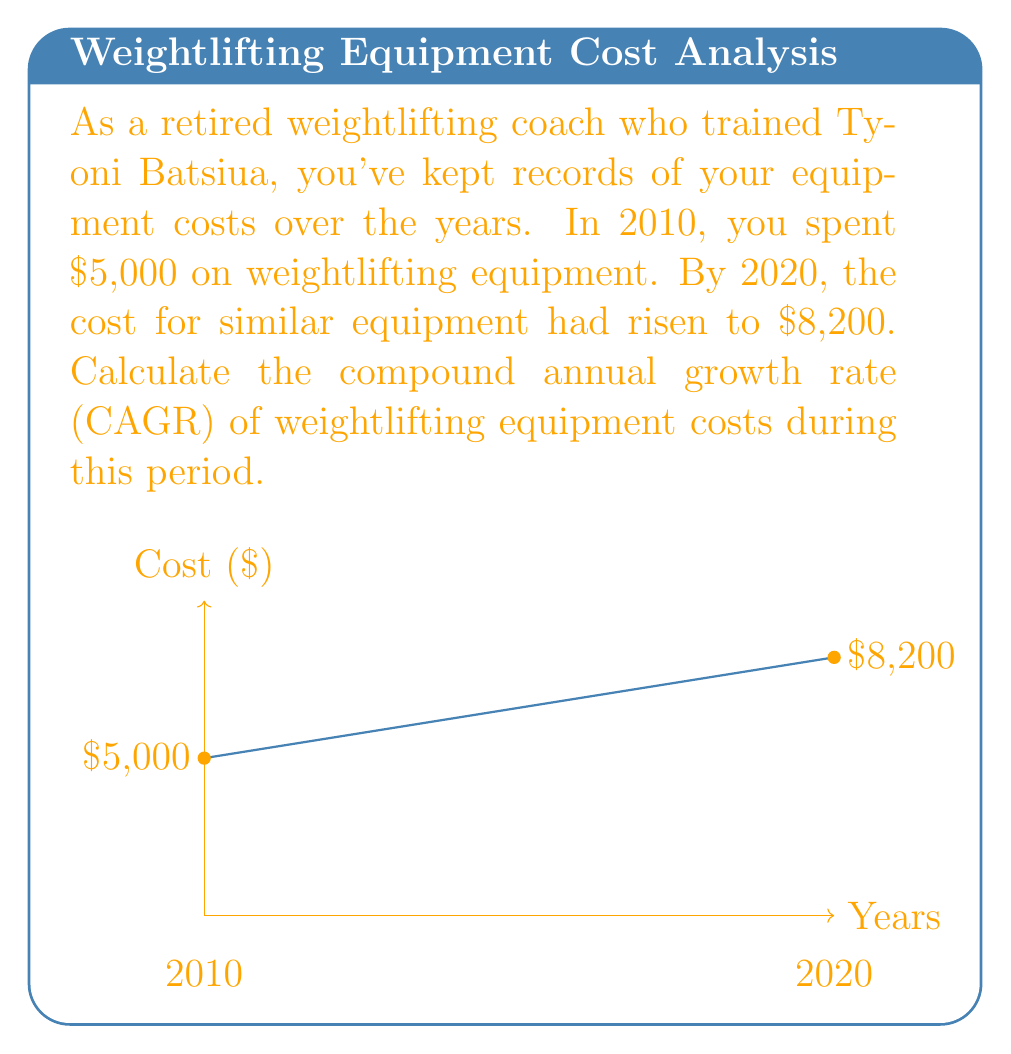Provide a solution to this math problem. To calculate the Compound Annual Growth Rate (CAGR), we use the formula:

$$ CAGR = \left(\frac{Ending Value}{Beginning Value}\right)^{\frac{1}{n}} - 1 $$

Where:
- Ending Value = $8,200
- Beginning Value = $5,000
- n = number of years = 10

Let's solve step by step:

1) Insert the values into the formula:

   $$ CAGR = \left(\frac{8,200}{5,000}\right)^{\frac{1}{10}} - 1 $$

2) Simplify inside the parentheses:

   $$ CAGR = (1.64)^{\frac{1}{10}} - 1 $$

3) Calculate the 10th root:

   $$ CAGR = 1.0507 - 1 $$

4) Subtract 1:

   $$ CAGR = 0.0507 $$

5) Convert to percentage:

   $$ CAGR = 5.07\% $$

Therefore, the compound annual growth rate of weightlifting equipment costs over the 10-year period is approximately 5.07%.
Answer: 5.07% 